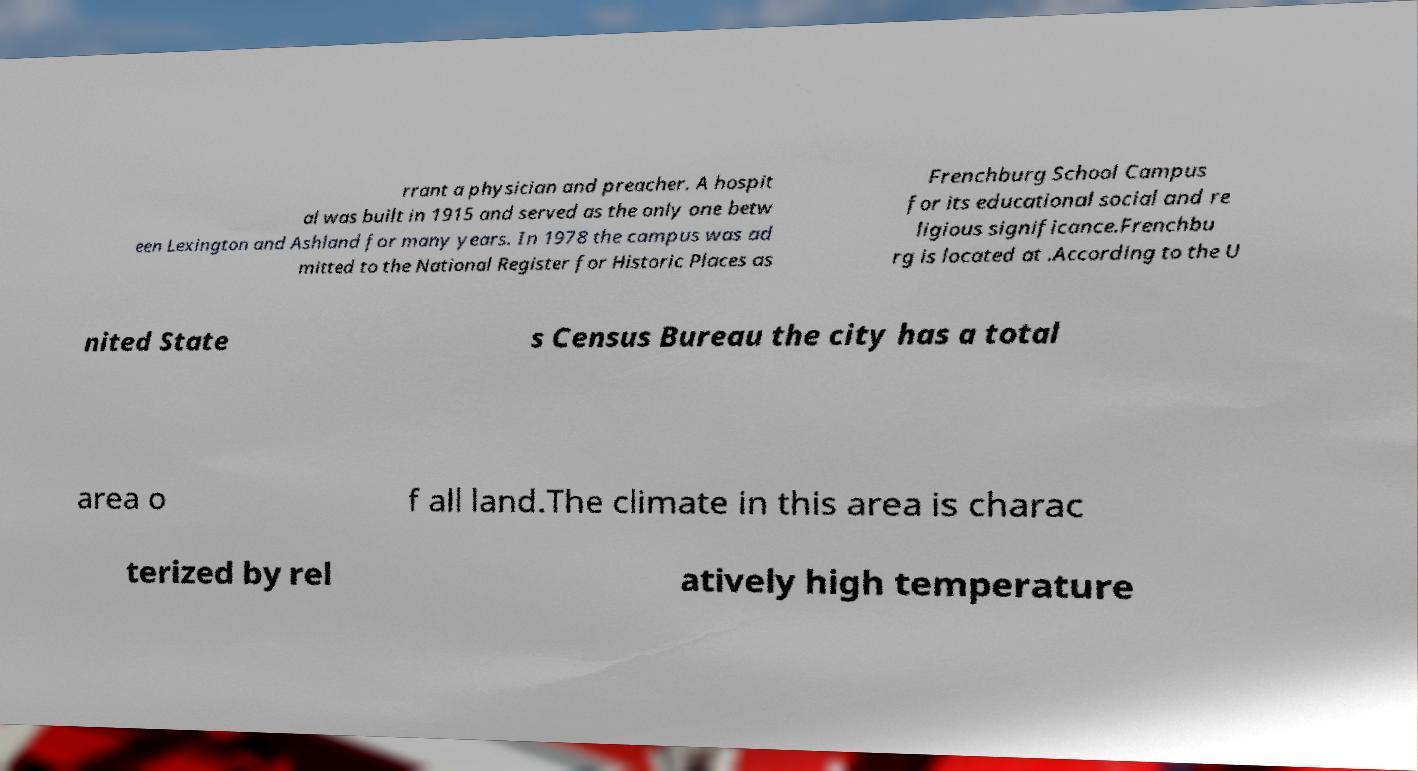There's text embedded in this image that I need extracted. Can you transcribe it verbatim? rrant a physician and preacher. A hospit al was built in 1915 and served as the only one betw een Lexington and Ashland for many years. In 1978 the campus was ad mitted to the National Register for Historic Places as Frenchburg School Campus for its educational social and re ligious significance.Frenchbu rg is located at .According to the U nited State s Census Bureau the city has a total area o f all land.The climate in this area is charac terized by rel atively high temperature 